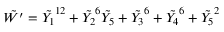Convert formula to latex. <formula><loc_0><loc_0><loc_500><loc_500>\tilde { W ^ { \prime } } = \tilde { Y _ { 1 } } ^ { 1 2 } + \tilde { Y _ { 2 } } ^ { 6 } \tilde { Y _ { 5 } } + \tilde { Y _ { 3 } } ^ { 6 } + \tilde { Y _ { 4 } } ^ { 6 } + \tilde { Y _ { 5 } } ^ { 2 }</formula> 